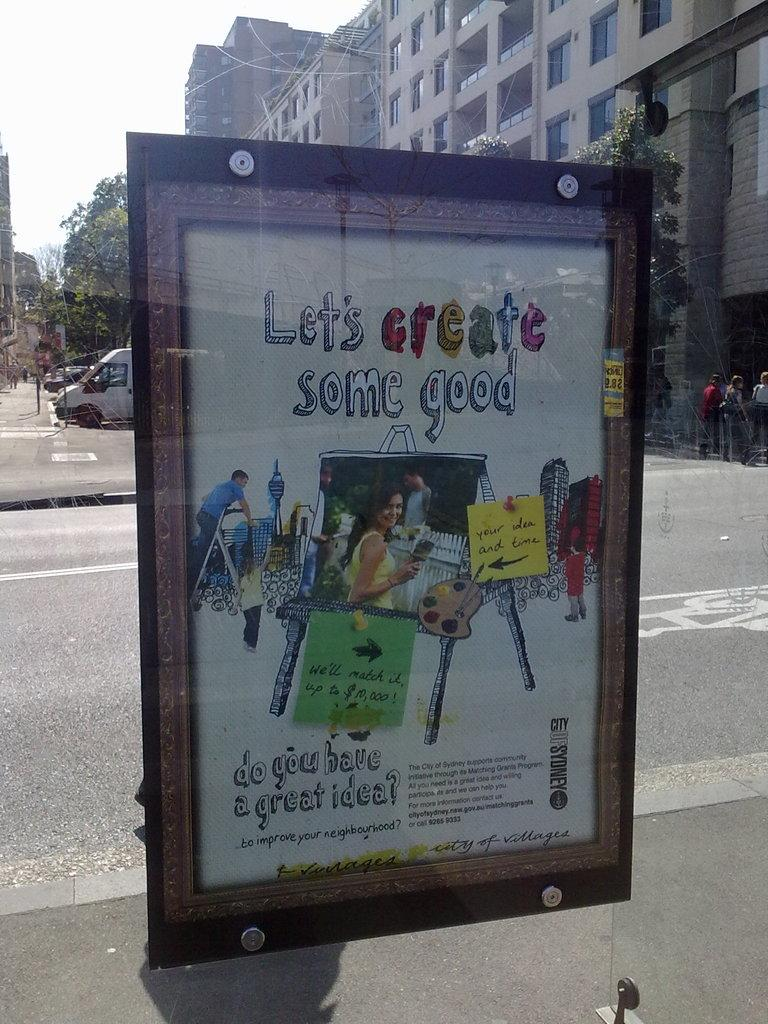Provide a one-sentence caption for the provided image. An outdoor advertisement encourages people to create some good. 